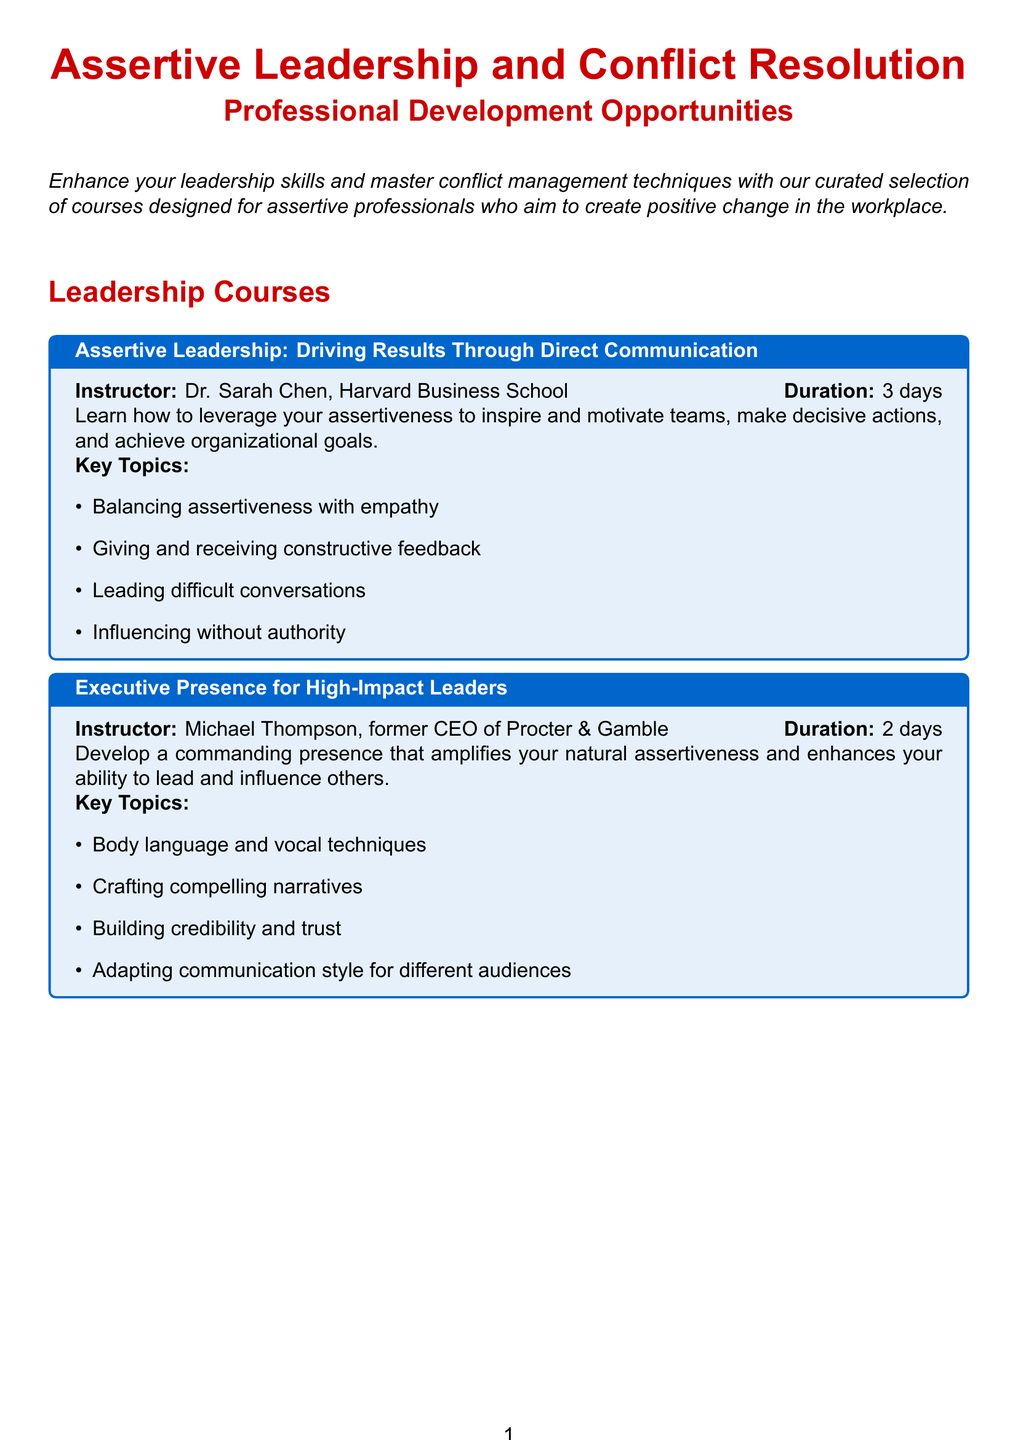What is the title of the catalog? The title of the catalog is stated at the beginning, providing an overview of the content focus.
Answer: Assertive Leadership and Conflict Resolution: Professional Development Opportunities Who is the instructor of the course on assertive leadership? The instructor's name is listed under the specific course, giving acknowledgment to their expertise.
Answer: Dr. Sarah Chen, Harvard Business School How many days is the seminar on mastering workplace confrontations? The duration is explicitly mentioned alongside the seminar title, defining the time commitment required.
Answer: 1 day What key topic is included in the emotional intelligence course? Key topics are listed under each course, showcasing the main areas of focus for attendees.
Answer: Managing strong emotions during conflicts Which course is offered by Michael Thompson? This question asks for a specific association of the instructor with their course, as detailed in the document.
Answer: Executive Presence for High-Impact Leaders How many leadership courses are available in this catalog? This question requires counting the entries under the leadership courses section, providing a quantitative assessment.
Answer: 2 What is the name of the facilitator for the conflict management seminar? The facilitator's name is provided alongside the seminar title, highlighting their qualifications.
Answer: Dr. Amanda Rodriguez, Conflict Resolution Expert Which reading book emphasizes assertiveness? The recommended reading section contains titles that focus on various topics, including assertiveness.
Answer: The Assertiveness Workbook: How to Express Your Ideas and Stand Up for Yourself at Work and in Relationships 